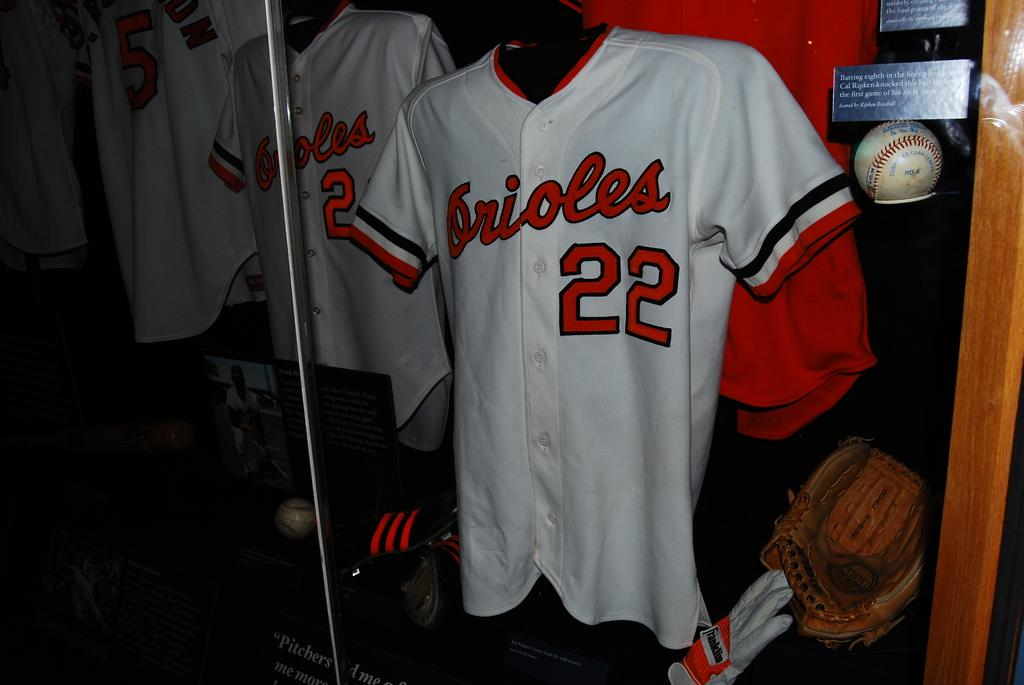<image>
Present a compact description of the photo's key features. Orioles uniforms are displayed in a window along with some equipment and gear. 